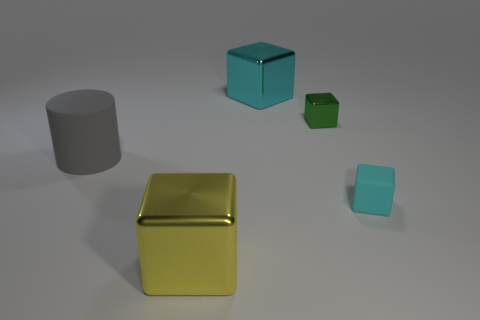How many other big metal objects are the same shape as the yellow metallic object? There is exactly one other big metal object having the same shape as the yellow metallic cube, which is the blue metallic cube. 